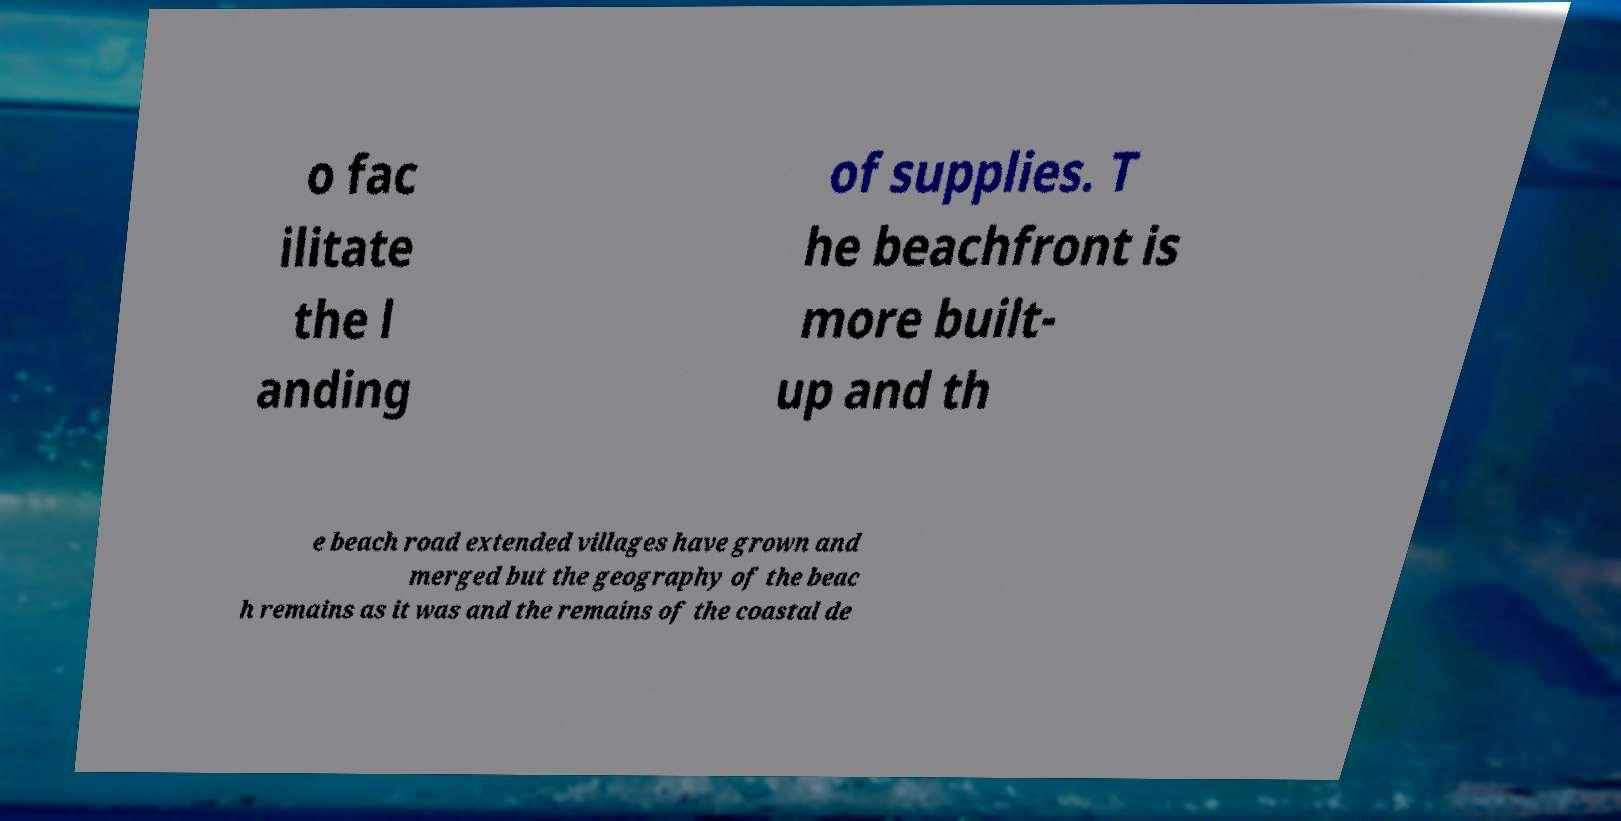Can you accurately transcribe the text from the provided image for me? o fac ilitate the l anding of supplies. T he beachfront is more built- up and th e beach road extended villages have grown and merged but the geography of the beac h remains as it was and the remains of the coastal de 